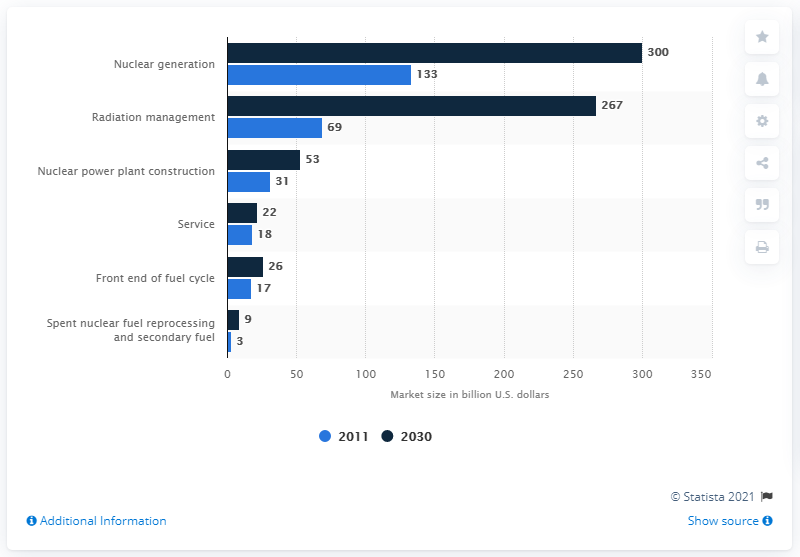Point out several critical features in this image. By 2030, the global nuclear generation segment is expected to reach approximately 300. 